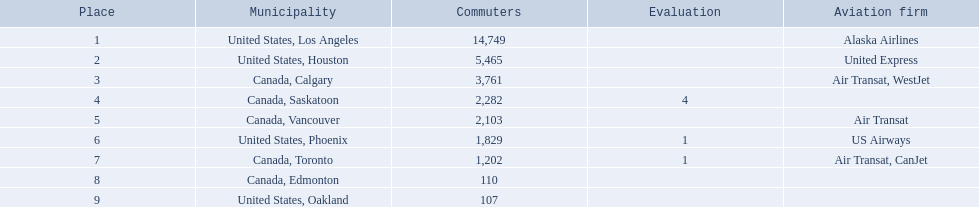Where are the destinations of the airport? United States, Los Angeles, United States, Houston, Canada, Calgary, Canada, Saskatoon, Canada, Vancouver, United States, Phoenix, Canada, Toronto, Canada, Edmonton, United States, Oakland. What is the number of passengers to phoenix? 1,829. 